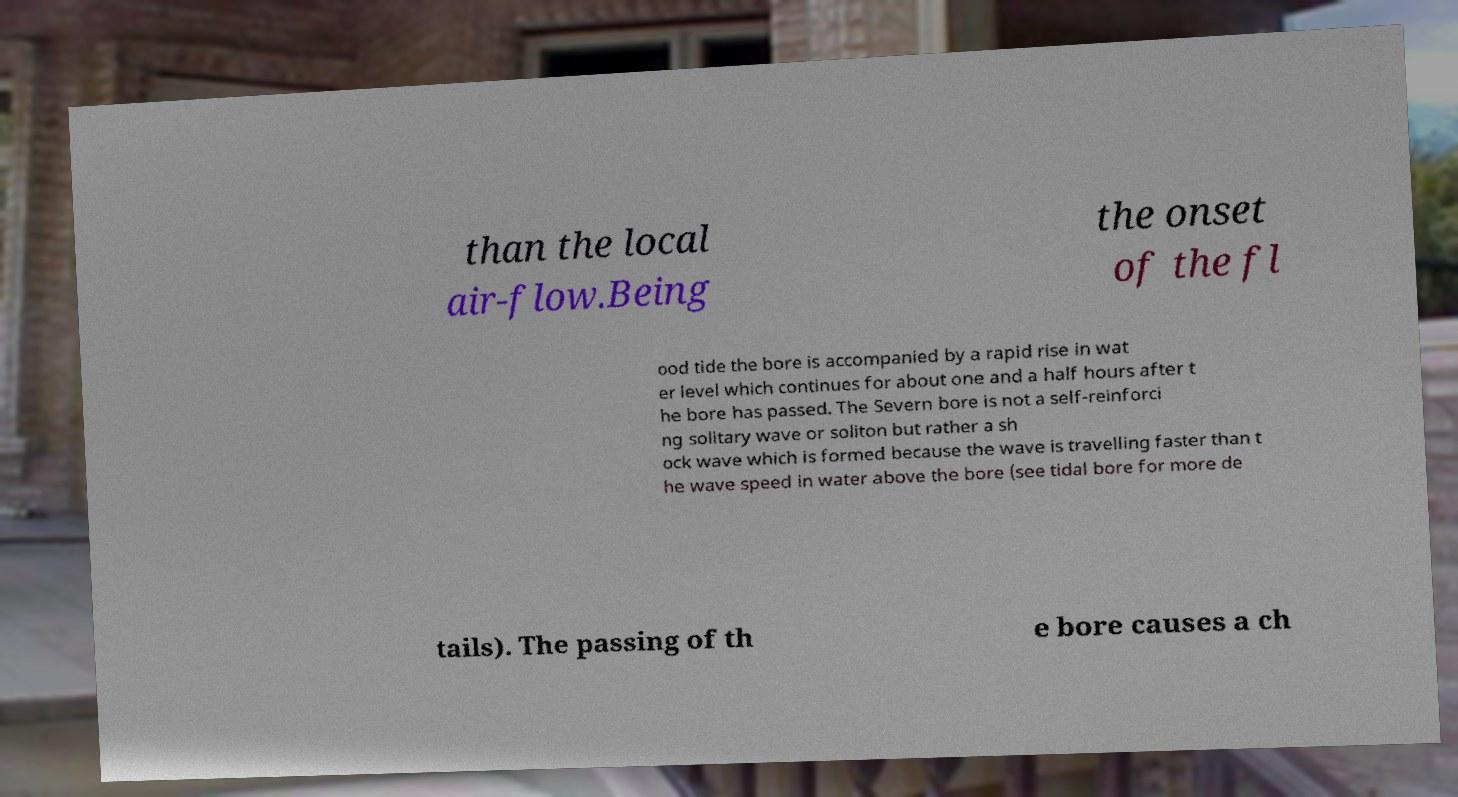Can you accurately transcribe the text from the provided image for me? than the local air-flow.Being the onset of the fl ood tide the bore is accompanied by a rapid rise in wat er level which continues for about one and a half hours after t he bore has passed. The Severn bore is not a self-reinforci ng solitary wave or soliton but rather a sh ock wave which is formed because the wave is travelling faster than t he wave speed in water above the bore (see tidal bore for more de tails). The passing of th e bore causes a ch 